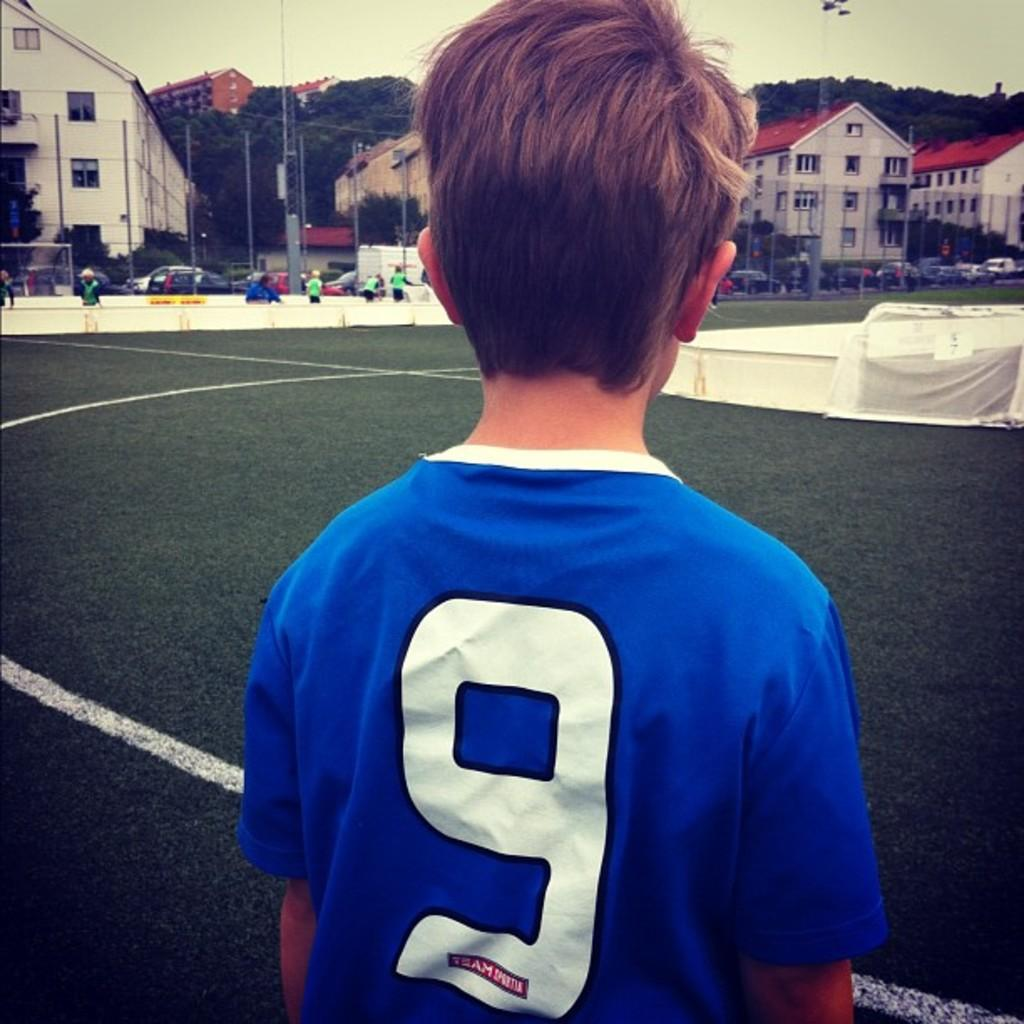<image>
Present a compact description of the photo's key features. Boy wearing a blue shirt which has the number 9 on the back. 